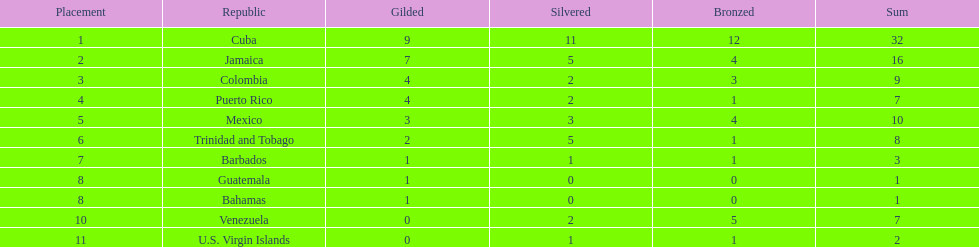Parse the full table. {'header': ['Placement', 'Republic', 'Gilded', 'Silvered', 'Bronzed', 'Sum'], 'rows': [['1', 'Cuba', '9', '11', '12', '32'], ['2', 'Jamaica', '7', '5', '4', '16'], ['3', 'Colombia', '4', '2', '3', '9'], ['4', 'Puerto Rico', '4', '2', '1', '7'], ['5', 'Mexico', '3', '3', '4', '10'], ['6', 'Trinidad and Tobago', '2', '5', '1', '8'], ['7', 'Barbados', '1', '1', '1', '3'], ['8', 'Guatemala', '1', '0', '0', '1'], ['8', 'Bahamas', '1', '0', '0', '1'], ['10', 'Venezuela', '0', '2', '5', '7'], ['11', 'U.S. Virgin Islands', '0', '1', '1', '2']]} Largest medal differential between countries 31. 